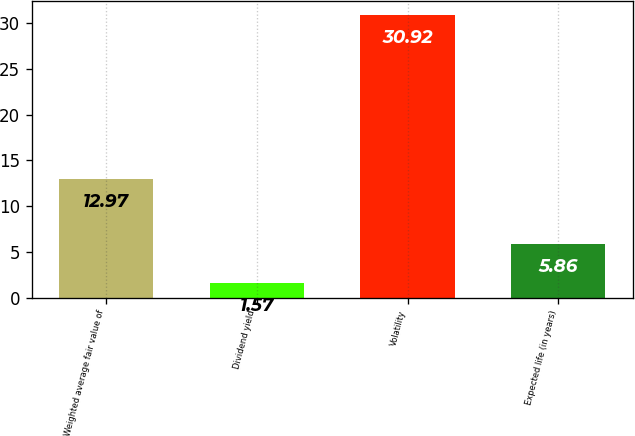<chart> <loc_0><loc_0><loc_500><loc_500><bar_chart><fcel>Weighted average fair value of<fcel>Dividend yield<fcel>Volatility<fcel>Expected life (in years)<nl><fcel>12.97<fcel>1.57<fcel>30.92<fcel>5.86<nl></chart> 